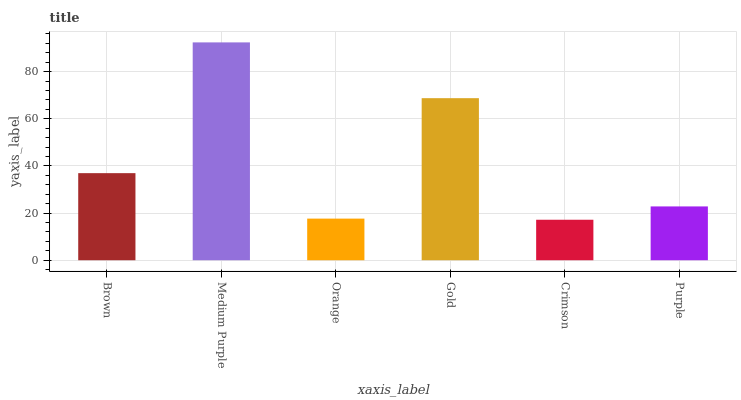Is Crimson the minimum?
Answer yes or no. Yes. Is Medium Purple the maximum?
Answer yes or no. Yes. Is Orange the minimum?
Answer yes or no. No. Is Orange the maximum?
Answer yes or no. No. Is Medium Purple greater than Orange?
Answer yes or no. Yes. Is Orange less than Medium Purple?
Answer yes or no. Yes. Is Orange greater than Medium Purple?
Answer yes or no. No. Is Medium Purple less than Orange?
Answer yes or no. No. Is Brown the high median?
Answer yes or no. Yes. Is Purple the low median?
Answer yes or no. Yes. Is Gold the high median?
Answer yes or no. No. Is Orange the low median?
Answer yes or no. No. 